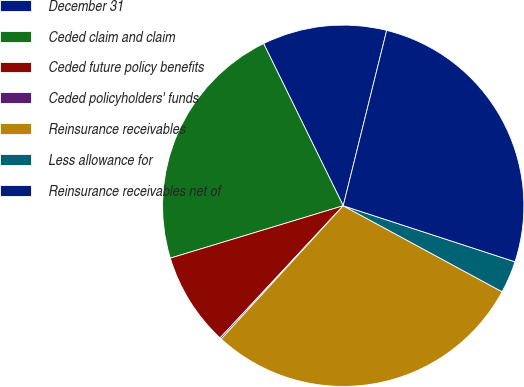Convert chart. <chart><loc_0><loc_0><loc_500><loc_500><pie_chart><fcel>December 31<fcel>Ceded claim and claim<fcel>Ceded future policy benefits<fcel>Ceded policyholders' funds<fcel>Reinsurance receivables<fcel>Less allowance for<fcel>Reinsurance receivables net of<nl><fcel>11.13%<fcel>22.42%<fcel>8.38%<fcel>0.14%<fcel>28.9%<fcel>2.88%<fcel>26.15%<nl></chart> 